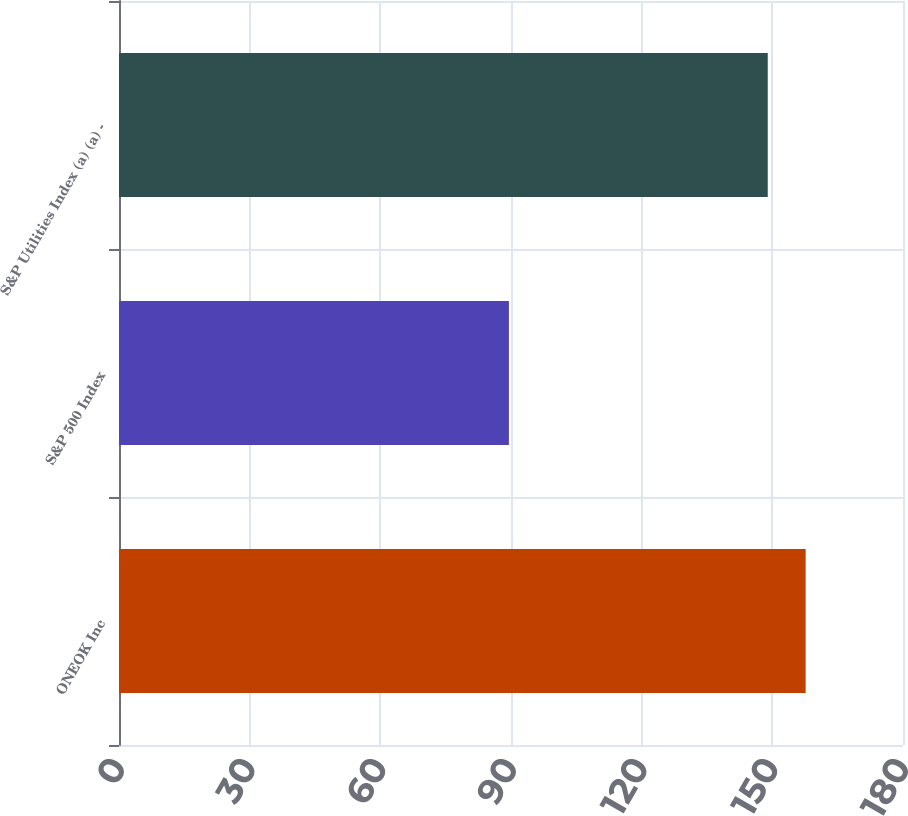Convert chart. <chart><loc_0><loc_0><loc_500><loc_500><bar_chart><fcel>ONEOK Inc<fcel>S&P 500 Index<fcel>S&P Utilities Index (a) (a) -<nl><fcel>157.65<fcel>89.52<fcel>148.95<nl></chart> 